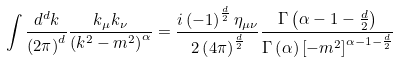Convert formula to latex. <formula><loc_0><loc_0><loc_500><loc_500>\int \frac { d ^ { d } k } { \left ( 2 \pi \right ) ^ { d } } \frac { k _ { \mu } k _ { \nu } } { \left ( k ^ { 2 } - m ^ { 2 } \right ) ^ { \alpha } } = \frac { i \left ( - 1 \right ) ^ { \frac { d } { 2 } } \eta _ { \mu \nu } } { 2 \left ( 4 \pi \right ) ^ { \frac { d } { 2 } } } \frac { \Gamma \left ( \alpha - 1 - \frac { d } { 2 } \right ) } { \Gamma \left ( \alpha \right ) \left [ - m ^ { 2 } \right ] ^ { \alpha - 1 - \frac { d } { 2 } } }</formula> 